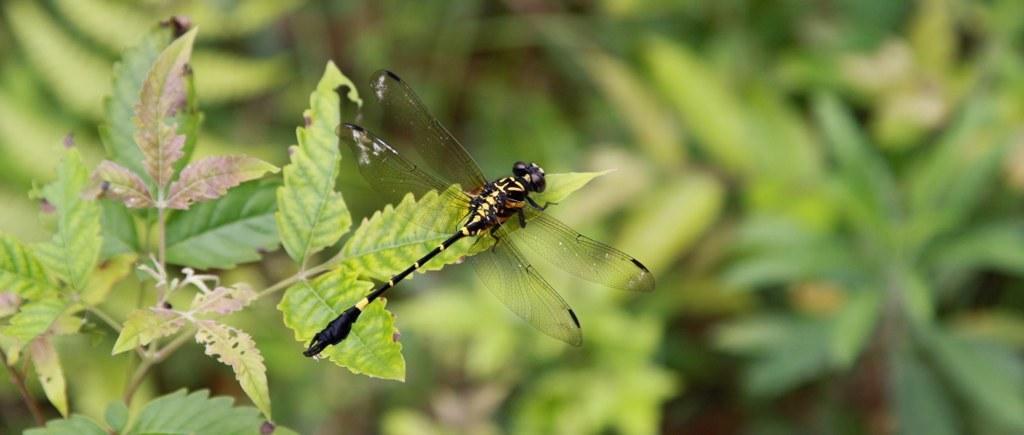Describe this image in one or two sentences. In this image there is an insect on the leaf of a plant. The background is greenery. 